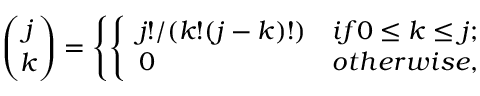Convert formula to latex. <formula><loc_0><loc_0><loc_500><loc_500>{ \binom { j } { k } } = \left \{ \left \{ \begin{array} { l l } { j ! / ( k ! ( j - k ) ! ) } & { i f 0 \leq k \leq j ; } \\ { 0 } & { o t h e r w i s e , } \end{array}</formula> 